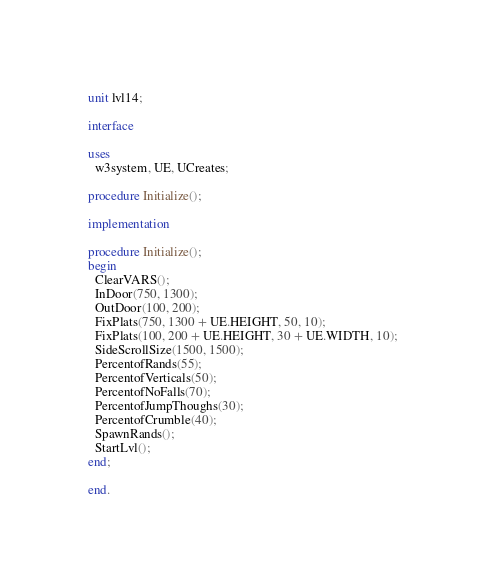Convert code to text. <code><loc_0><loc_0><loc_500><loc_500><_Pascal_>unit lvl14;

interface

uses
  w3system, UE, UCreates;

procedure Initialize();

implementation

procedure Initialize();
begin
  ClearVARS();
  InDoor(750, 1300);
  OutDoor(100, 200);
  FixPlats(750, 1300 + UE.HEIGHT, 50, 10);
  FixPlats(100, 200 + UE.HEIGHT, 30 + UE.WIDTH, 10);
  SideScrollSize(1500, 1500);
  PercentofRands(55);
  PercentofVerticals(50);
  PercentofNoFalls(70);
  PercentofJumpThoughs(30);
  PercentofCrumble(40);
  SpawnRands();
  StartLvl();
end;

end.</code> 